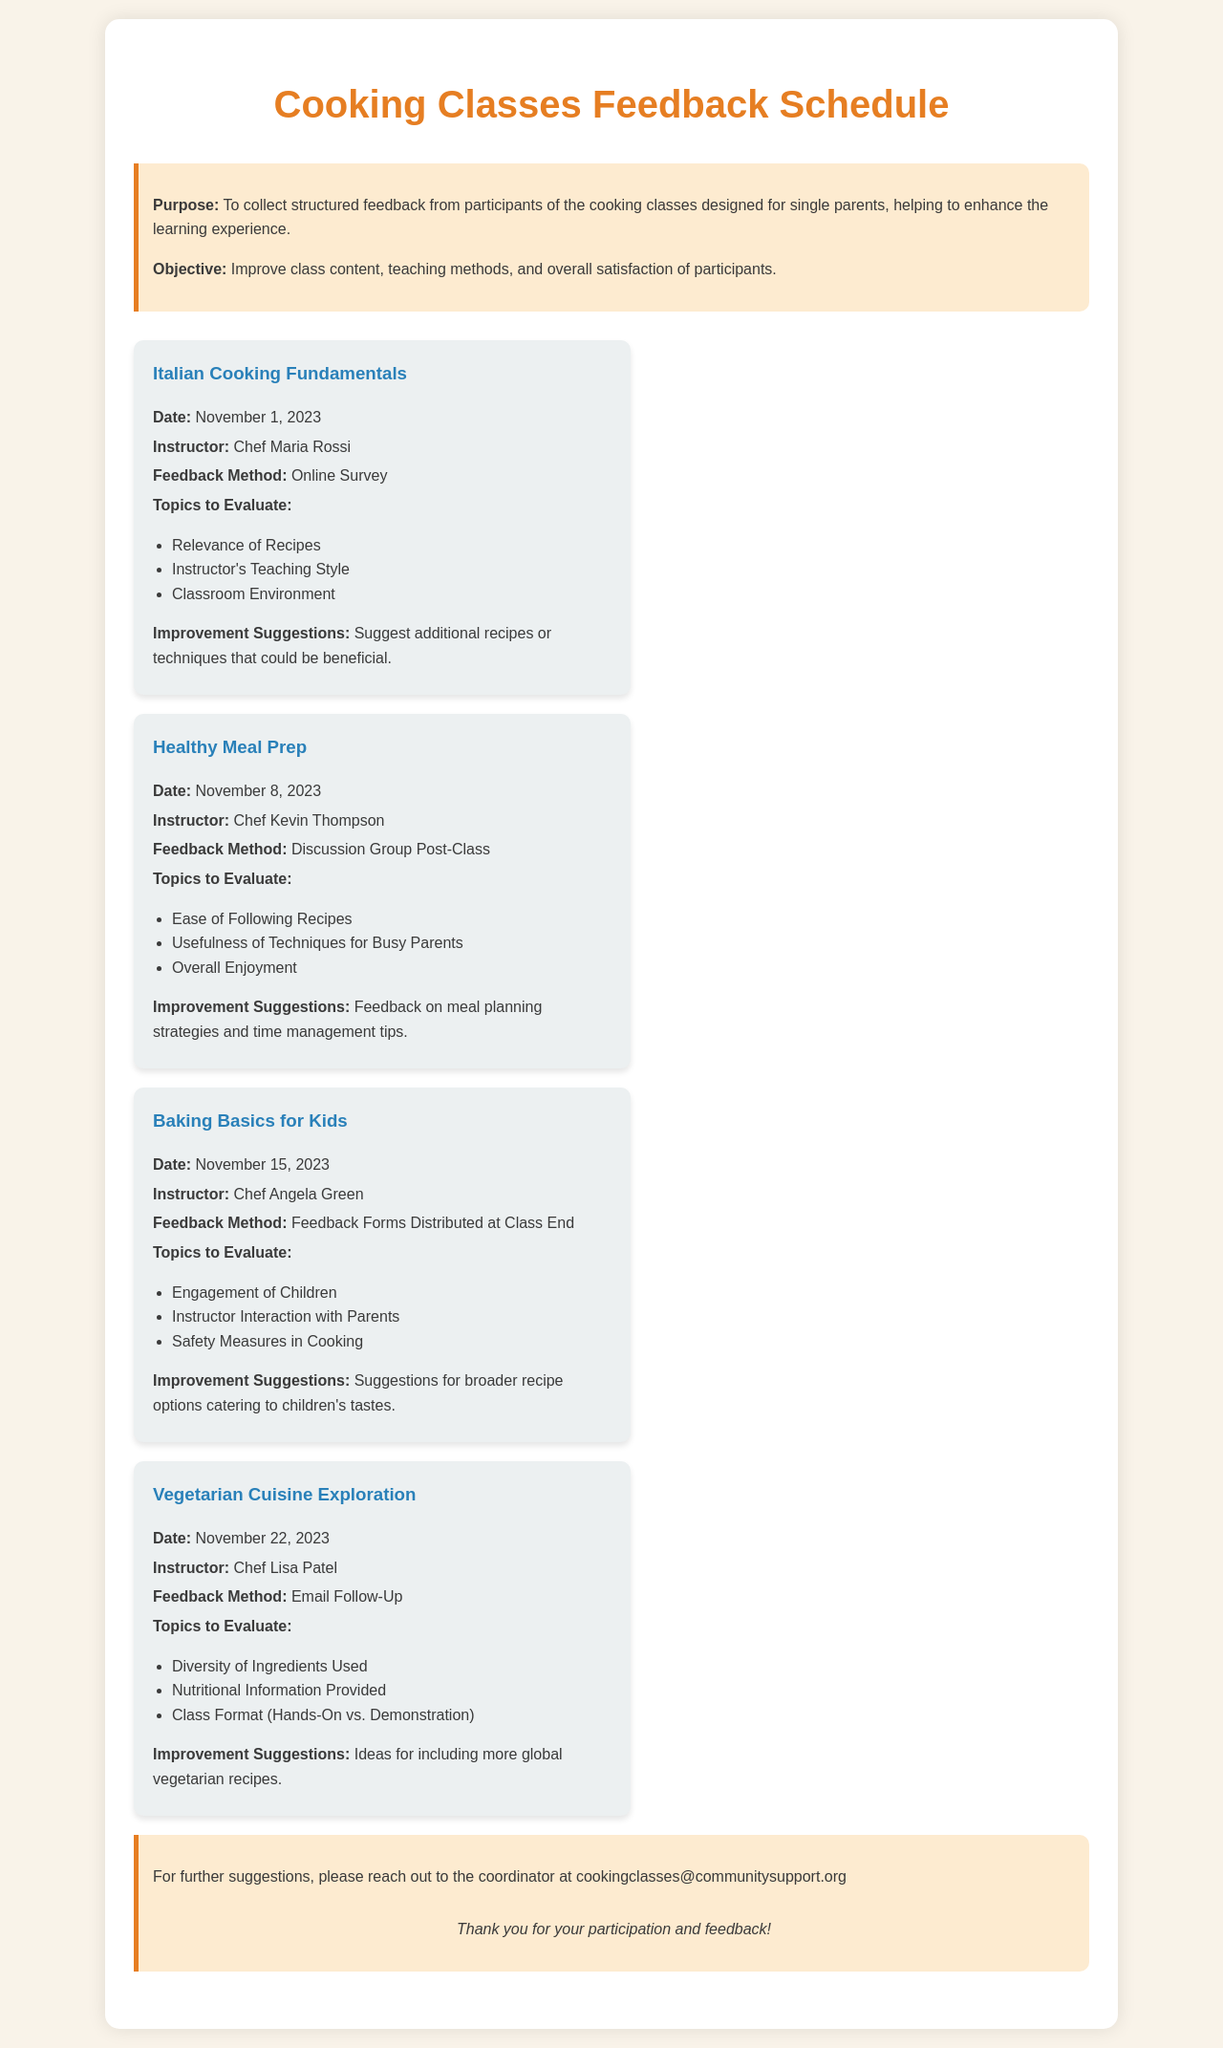What is the date of the Italian Cooking Fundamentals class? The date for this class is clearly stated in the document.
Answer: November 1, 2023 Who is the instructor for the Healthy Meal Prep class? The instructor's name is mentioned in relation to the Healthy Meal Prep class within the document.
Answer: Chef Kevin Thompson What method is used to gather feedback for the Baking Basics for Kids class? The feedback method for this class is specified in the document.
Answer: Feedback Forms Distributed at Class End What are participants asked to suggest as improvements for the Italian Cooking Fundamentals class? Improvement suggestions for this class are listed in the document.
Answer: Suggest additional recipes or techniques that could be beneficial How many topics are participants asked to evaluate in the Vegetarian Cuisine Exploration class? The number of topics to evaluate is provided in the section regarding this class.
Answer: Three What is the email address provided for further suggestions? The document provides a specific contact email for participants.
Answer: cookingclasses@communitysupport.org 